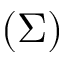<formula> <loc_0><loc_0><loc_500><loc_500>( \Sigma )</formula> 